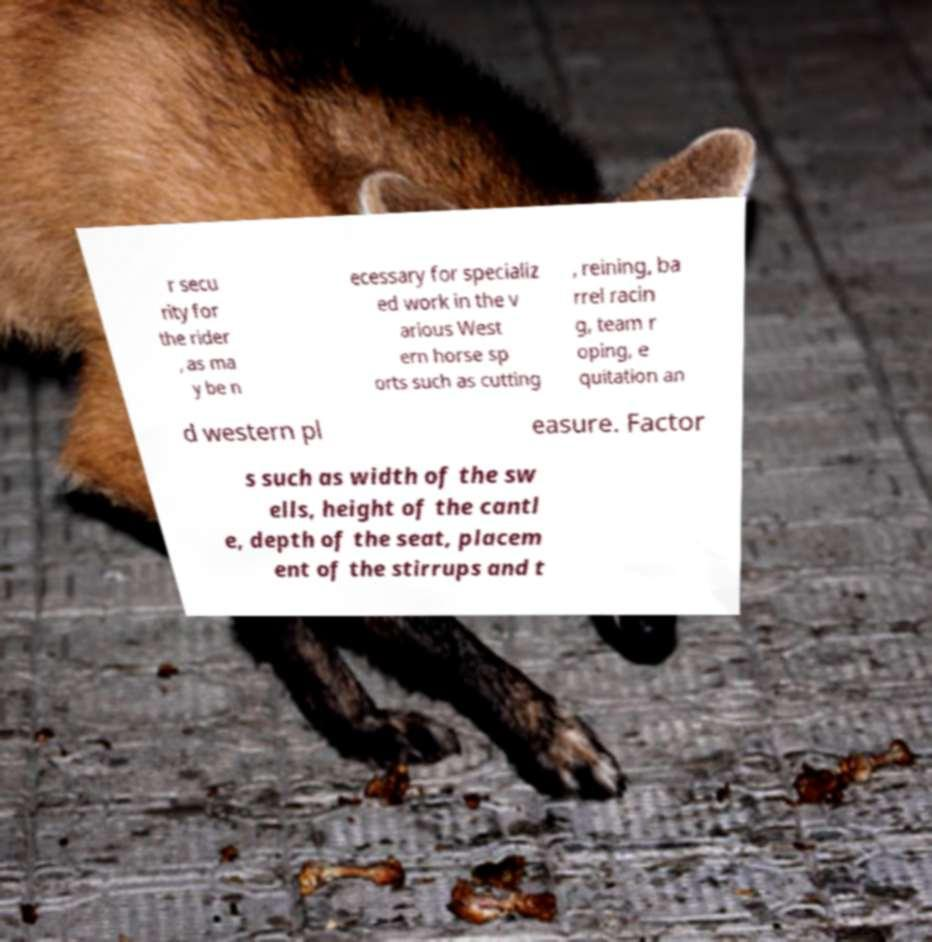Could you extract and type out the text from this image? r secu rity for the rider , as ma y be n ecessary for specializ ed work in the v arious West ern horse sp orts such as cutting , reining, ba rrel racin g, team r oping, e quitation an d western pl easure. Factor s such as width of the sw ells, height of the cantl e, depth of the seat, placem ent of the stirrups and t 